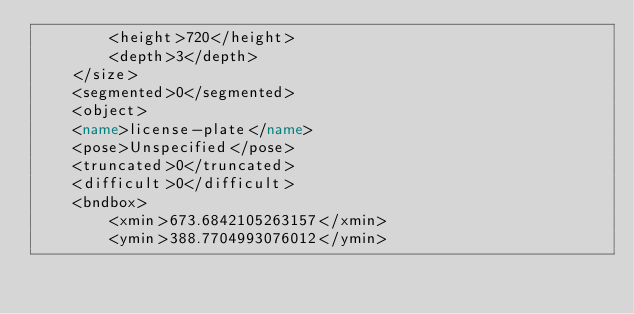<code> <loc_0><loc_0><loc_500><loc_500><_XML_>        <height>720</height>
        <depth>3</depth>
    </size>
    <segmented>0</segmented>
    <object>
    <name>license-plate</name>
    <pose>Unspecified</pose>
    <truncated>0</truncated>
    <difficult>0</difficult>
    <bndbox>
        <xmin>673.6842105263157</xmin>
        <ymin>388.7704993076012</ymin></code> 